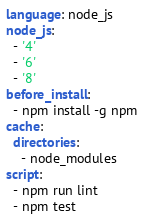Convert code to text. <code><loc_0><loc_0><loc_500><loc_500><_YAML_>language: node_js
node_js:
  - '4'
  - '6'
  - '8'
before_install:
  - npm install -g npm
cache:
  directories:
    - node_modules
script:
  - npm run lint
  - npm test
</code> 